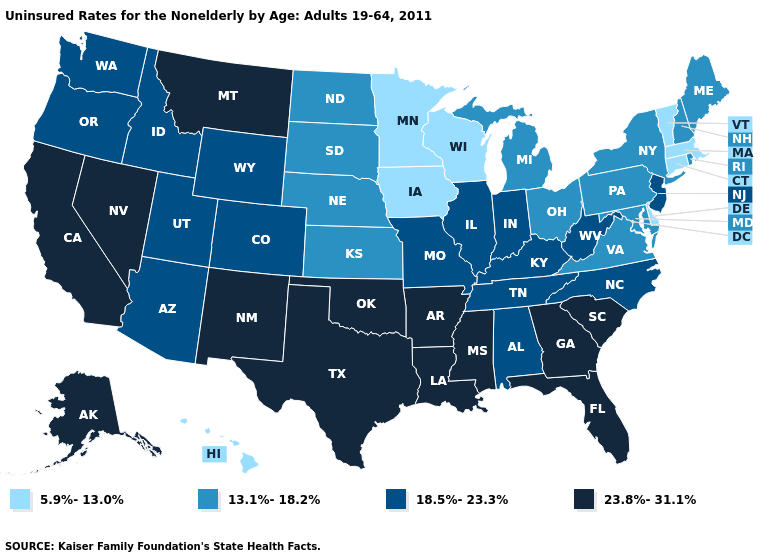Does the first symbol in the legend represent the smallest category?
Concise answer only. Yes. Does New Jersey have the same value as West Virginia?
Give a very brief answer. Yes. Among the states that border Kansas , which have the lowest value?
Be succinct. Nebraska. Name the states that have a value in the range 13.1%-18.2%?
Keep it brief. Kansas, Maine, Maryland, Michigan, Nebraska, New Hampshire, New York, North Dakota, Ohio, Pennsylvania, Rhode Island, South Dakota, Virginia. What is the lowest value in the MidWest?
Be succinct. 5.9%-13.0%. What is the value of Louisiana?
Answer briefly. 23.8%-31.1%. Name the states that have a value in the range 18.5%-23.3%?
Concise answer only. Alabama, Arizona, Colorado, Idaho, Illinois, Indiana, Kentucky, Missouri, New Jersey, North Carolina, Oregon, Tennessee, Utah, Washington, West Virginia, Wyoming. Among the states that border Nevada , which have the highest value?
Be succinct. California. Which states have the highest value in the USA?
Keep it brief. Alaska, Arkansas, California, Florida, Georgia, Louisiana, Mississippi, Montana, Nevada, New Mexico, Oklahoma, South Carolina, Texas. Which states have the highest value in the USA?
Answer briefly. Alaska, Arkansas, California, Florida, Georgia, Louisiana, Mississippi, Montana, Nevada, New Mexico, Oklahoma, South Carolina, Texas. Which states have the lowest value in the USA?
Be succinct. Connecticut, Delaware, Hawaii, Iowa, Massachusetts, Minnesota, Vermont, Wisconsin. Name the states that have a value in the range 5.9%-13.0%?
Short answer required. Connecticut, Delaware, Hawaii, Iowa, Massachusetts, Minnesota, Vermont, Wisconsin. What is the highest value in states that border Tennessee?
Give a very brief answer. 23.8%-31.1%. Does South Carolina have a higher value than California?
Short answer required. No. Which states have the lowest value in the South?
Be succinct. Delaware. 